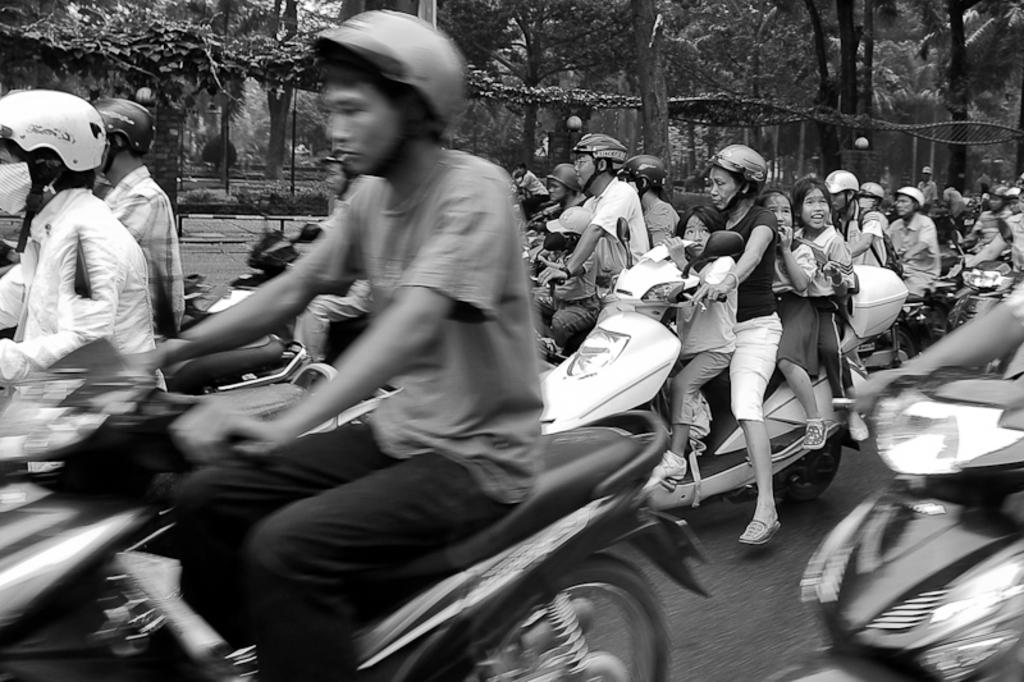What are the people in the image doing? There is a group of persons riding bikes in the image. Are there any other people involved in the activity? Yes, some people are sitting on the back and in front of the bike riders. What can be seen in the background of the image? There are trees beside the group of persons. What type of hair can be seen on the trees in the image? There is no hair present on the trees in the image; they are natural vegetation. What sound can be heard coming from the stitch in the image? There is no stitch present in the image, and therefore no sound can be heard from it. 